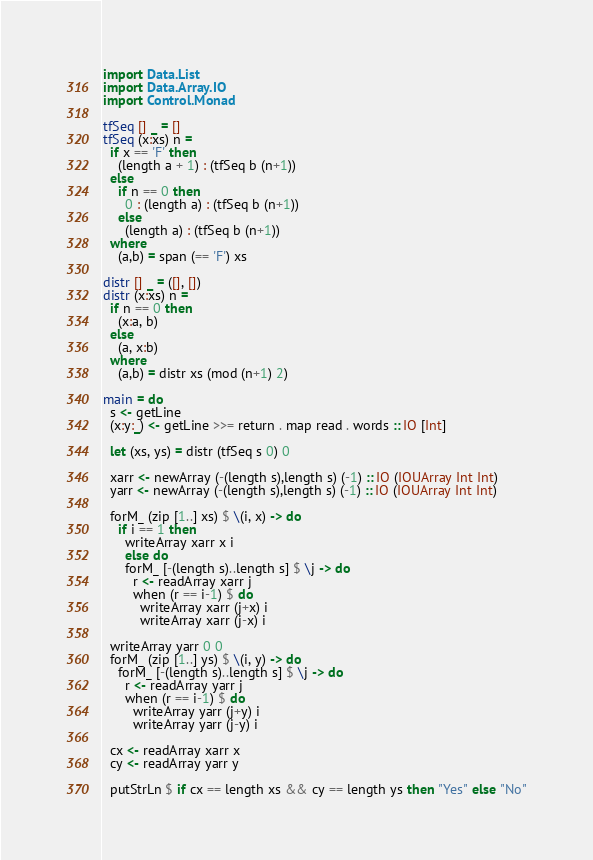Convert code to text. <code><loc_0><loc_0><loc_500><loc_500><_Haskell_>import Data.List
import Data.Array.IO
import Control.Monad

tfSeq [] _ = []
tfSeq (x:xs) n =
  if x == 'F' then
    (length a + 1) : (tfSeq b (n+1))
  else
    if n == 0 then
      0 : (length a) : (tfSeq b (n+1))
    else
      (length a) : (tfSeq b (n+1))
  where
    (a,b) = span (== 'F') xs

distr [] _ = ([], [])
distr (x:xs) n =
  if n == 0 then
    (x:a, b)
  else
    (a, x:b)
  where
    (a,b) = distr xs (mod (n+1) 2)
  
main = do
  s <- getLine
  (x:y:_) <- getLine >>= return . map read . words :: IO [Int]

  let (xs, ys) = distr (tfSeq s 0) 0
  
  xarr <- newArray (-(length s),length s) (-1) :: IO (IOUArray Int Int)
  yarr <- newArray (-(length s),length s) (-1) :: IO (IOUArray Int Int)

  forM_ (zip [1..] xs) $ \(i, x) -> do
    if i == 1 then
      writeArray xarr x i
      else do
      forM_ [-(length s)..length s] $ \j -> do
        r <- readArray xarr j
        when (r == i-1) $ do
          writeArray xarr (j+x) i
          writeArray xarr (j-x) i

  writeArray yarr 0 0
  forM_ (zip [1..] ys) $ \(i, y) -> do
    forM_ [-(length s)..length s] $ \j -> do
      r <- readArray yarr j
      when (r == i-1) $ do
        writeArray yarr (j+y) i
        writeArray yarr (j-y) i  
    
  cx <- readArray xarr x
  cy <- readArray yarr y
  
  putStrLn $ if cx == length xs && cy == length ys then "Yes" else "No"
</code> 